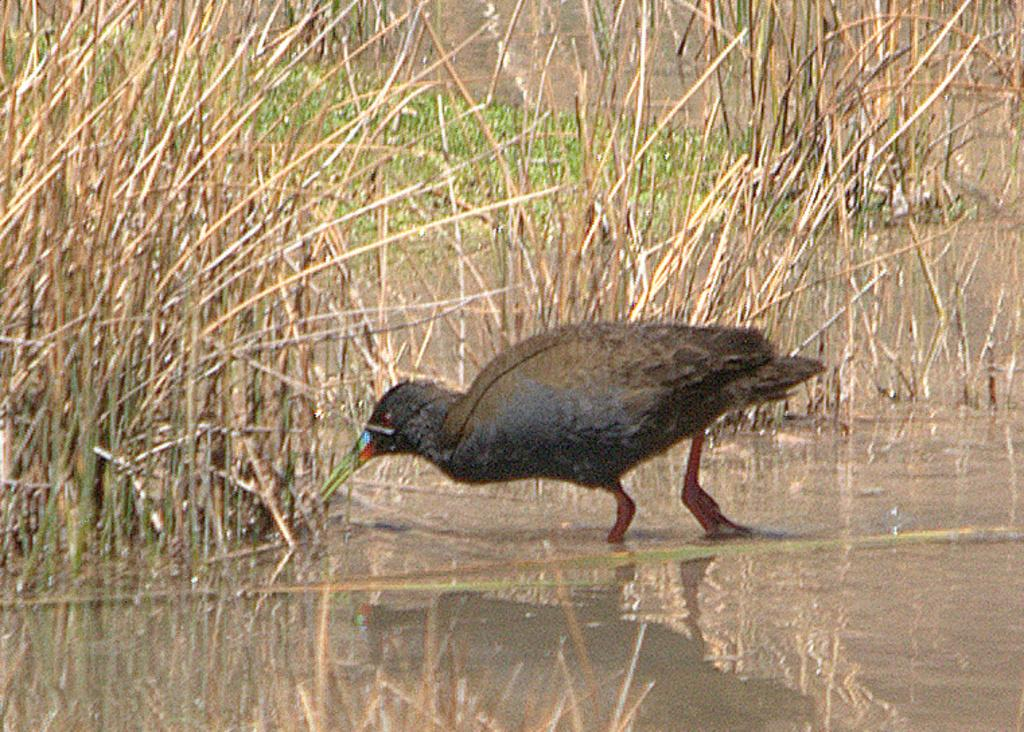What type of animal is in the image? There is a black color bird in the image. Where is the bird located? The bird is in the water. What else can be seen in the water besides the bird? There are plants in the water. What type of alley can be seen in the background of the image? There is no alley present in the image; it features a bird in the water with plants. 